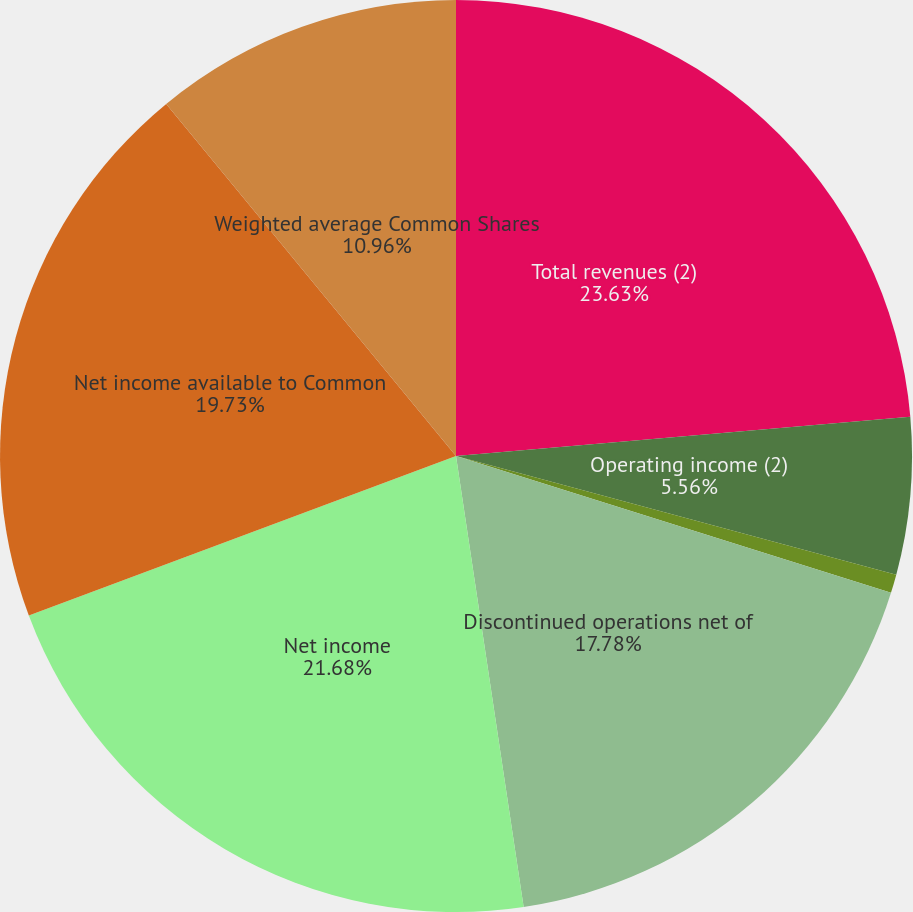Convert chart. <chart><loc_0><loc_0><loc_500><loc_500><pie_chart><fcel>Total revenues (2)<fcel>Operating income (2)<fcel>Income from continuing<fcel>Discontinued operations net of<fcel>Net income<fcel>Net income available to Common<fcel>Weighted average Common Shares<nl><fcel>23.63%<fcel>5.56%<fcel>0.66%<fcel>17.78%<fcel>21.68%<fcel>19.73%<fcel>10.96%<nl></chart> 